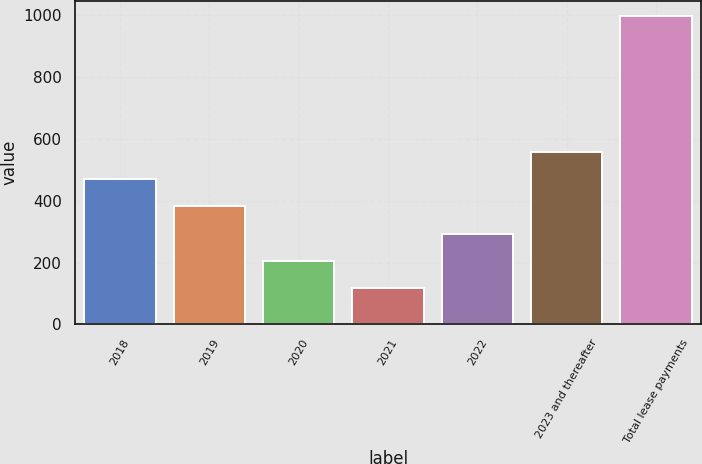Convert chart to OTSL. <chart><loc_0><loc_0><loc_500><loc_500><bar_chart><fcel>2018<fcel>2019<fcel>2020<fcel>2021<fcel>2022<fcel>2023 and thereafter<fcel>Total lease payments<nl><fcel>469.2<fcel>381.4<fcel>205.8<fcel>118<fcel>293.6<fcel>557<fcel>996<nl></chart> 